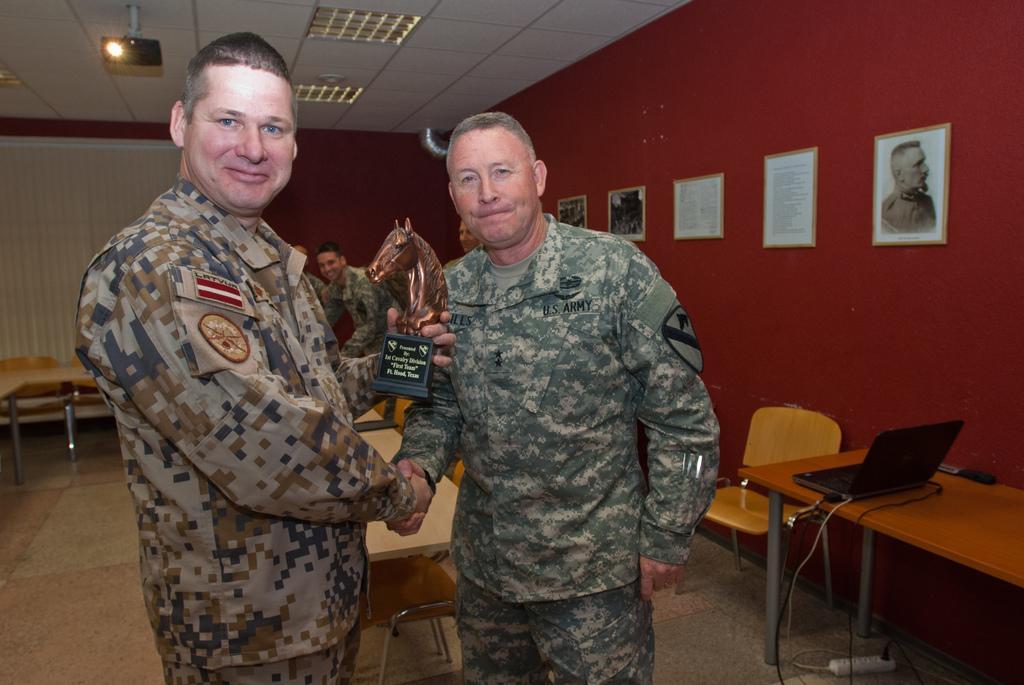In one or two sentences, can you explain what this image depicts? this picture shows two men standing and shaking their hands and we see a man standing on the back and we see few photo frames on the wall and a laptop on the table and couple of chairs and tables and we see projector screen on the top of the roof and a man holding a moment in his another hand 